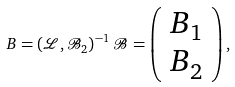<formula> <loc_0><loc_0><loc_500><loc_500>B = \left ( { \mathcal { L } } , { \mathcal { B } } _ { 2 } \right ) ^ { - 1 } { \mathcal { B } } = \left ( \begin{array} { l } B _ { 1 } \\ B _ { 2 } \end{array} \right ) ,</formula> 